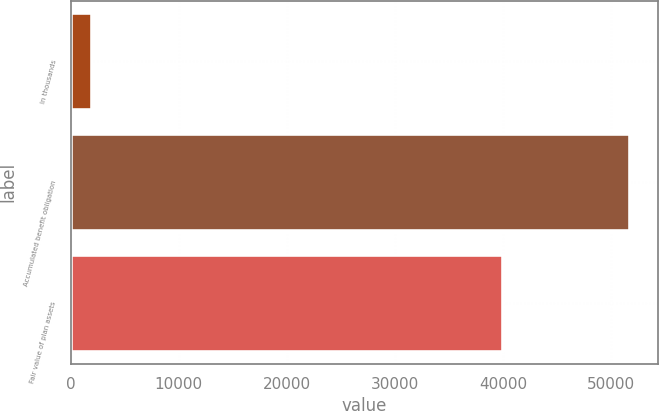Convert chart to OTSL. <chart><loc_0><loc_0><loc_500><loc_500><bar_chart><fcel>In thousands<fcel>Accumulated benefit obligation<fcel>Fair value of plan assets<nl><fcel>2011<fcel>51735<fcel>39951<nl></chart> 